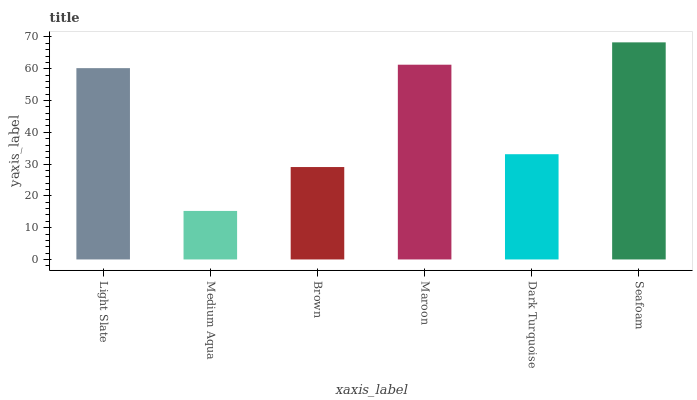Is Medium Aqua the minimum?
Answer yes or no. Yes. Is Seafoam the maximum?
Answer yes or no. Yes. Is Brown the minimum?
Answer yes or no. No. Is Brown the maximum?
Answer yes or no. No. Is Brown greater than Medium Aqua?
Answer yes or no. Yes. Is Medium Aqua less than Brown?
Answer yes or no. Yes. Is Medium Aqua greater than Brown?
Answer yes or no. No. Is Brown less than Medium Aqua?
Answer yes or no. No. Is Light Slate the high median?
Answer yes or no. Yes. Is Dark Turquoise the low median?
Answer yes or no. Yes. Is Maroon the high median?
Answer yes or no. No. Is Maroon the low median?
Answer yes or no. No. 